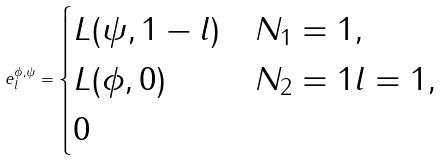<formula> <loc_0><loc_0><loc_500><loc_500>e _ { l } ^ { \phi , \psi } = \begin{cases} L ( \psi , 1 - l ) & N _ { 1 } = 1 , \\ L ( \phi , 0 ) & N _ { 2 } = 1 l = 1 , \\ 0 & \end{cases}</formula> 